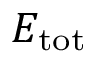Convert formula to latex. <formula><loc_0><loc_0><loc_500><loc_500>E _ { t o t }</formula> 